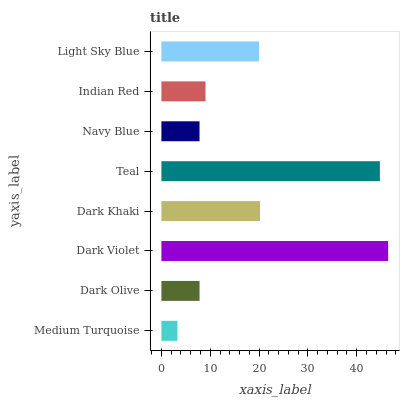Is Medium Turquoise the minimum?
Answer yes or no. Yes. Is Dark Violet the maximum?
Answer yes or no. Yes. Is Dark Olive the minimum?
Answer yes or no. No. Is Dark Olive the maximum?
Answer yes or no. No. Is Dark Olive greater than Medium Turquoise?
Answer yes or no. Yes. Is Medium Turquoise less than Dark Olive?
Answer yes or no. Yes. Is Medium Turquoise greater than Dark Olive?
Answer yes or no. No. Is Dark Olive less than Medium Turquoise?
Answer yes or no. No. Is Light Sky Blue the high median?
Answer yes or no. Yes. Is Indian Red the low median?
Answer yes or no. Yes. Is Navy Blue the high median?
Answer yes or no. No. Is Teal the low median?
Answer yes or no. No. 